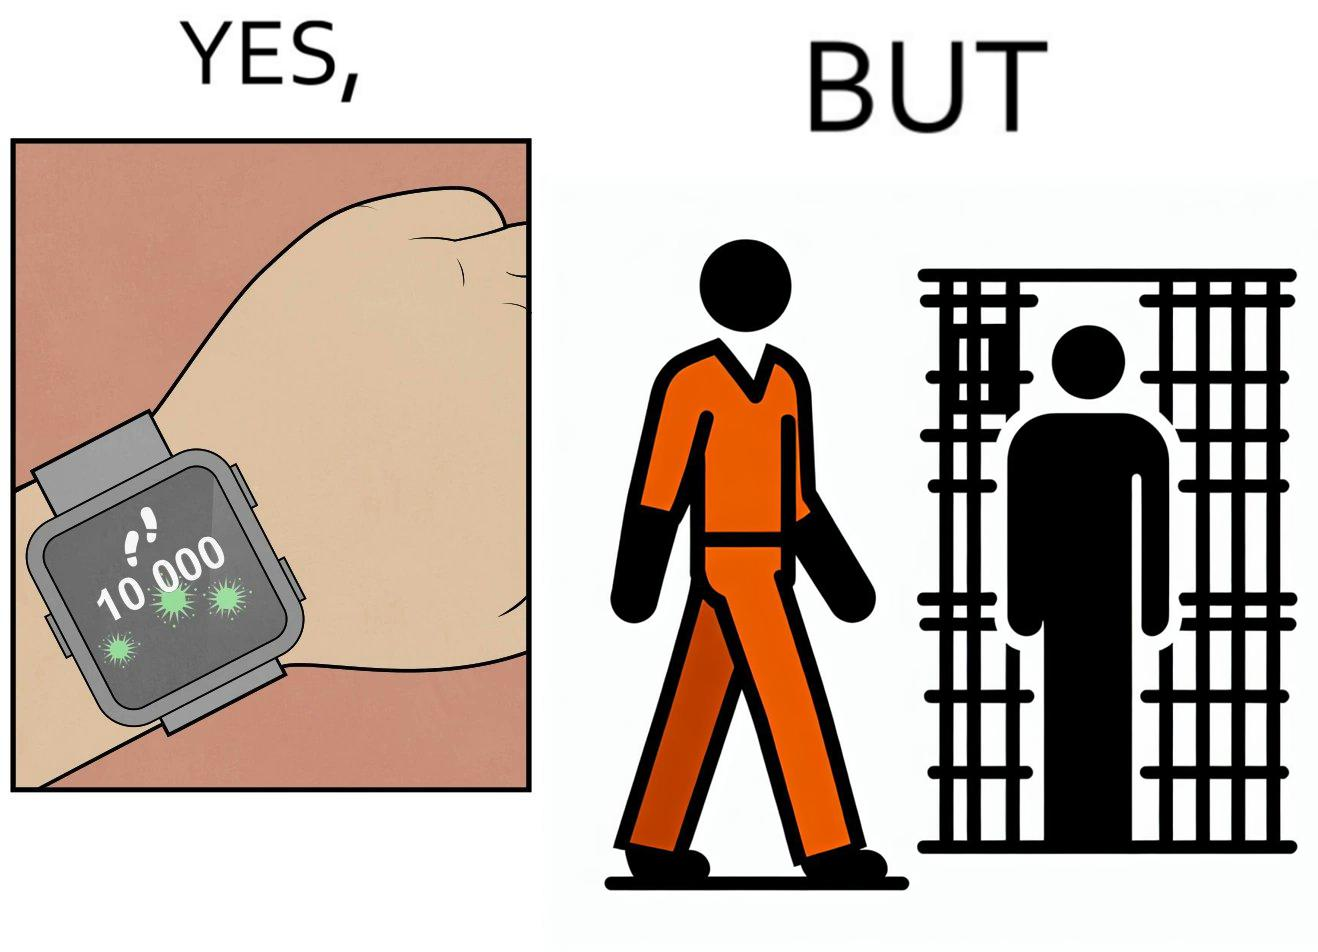What does this image depict? The image is ironical, as the smartwatch on the person's wrist shows 10,000 steps completed as an accomplishment, while showing later that the person is apparently walking inside a jail as a prisoner. 